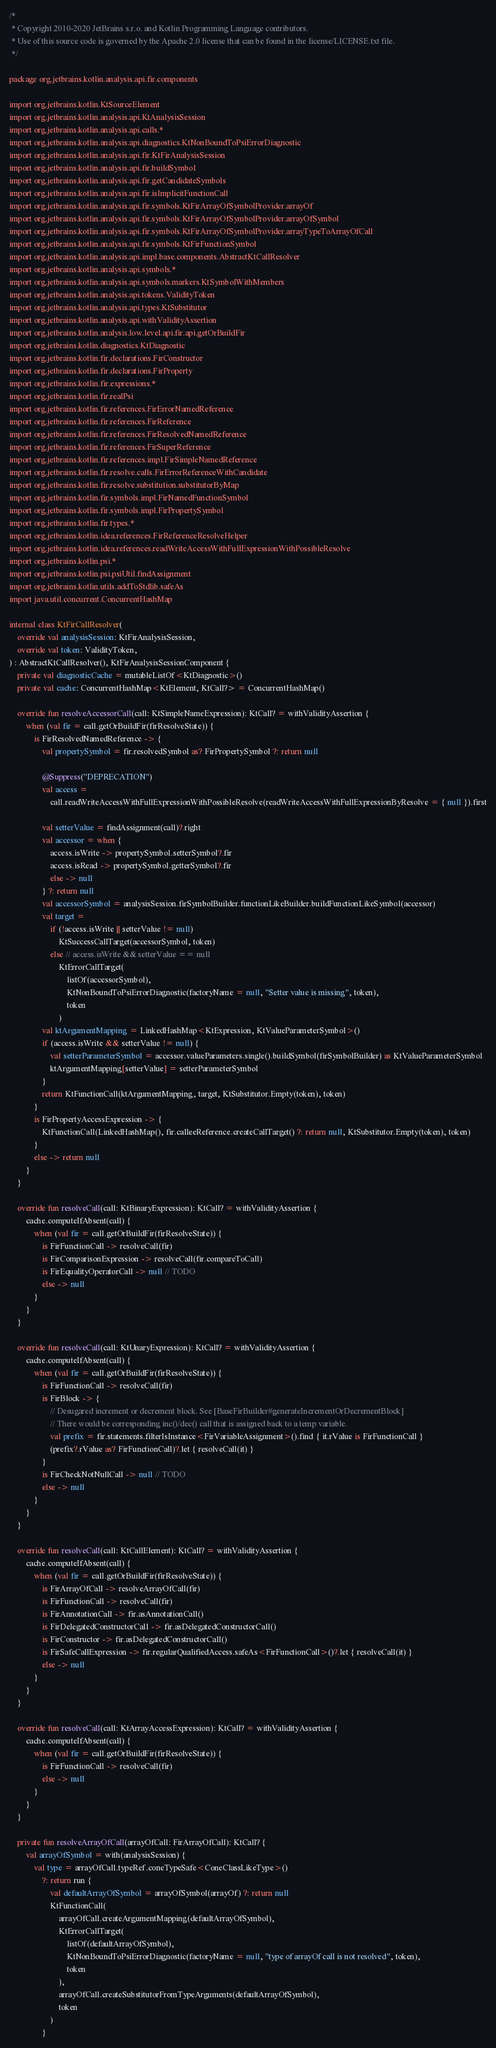<code> <loc_0><loc_0><loc_500><loc_500><_Kotlin_>/*
 * Copyright 2010-2020 JetBrains s.r.o. and Kotlin Programming Language contributors.
 * Use of this source code is governed by the Apache 2.0 license that can be found in the license/LICENSE.txt file.
 */

package org.jetbrains.kotlin.analysis.api.fir.components

import org.jetbrains.kotlin.KtSourceElement
import org.jetbrains.kotlin.analysis.api.KtAnalysisSession
import org.jetbrains.kotlin.analysis.api.calls.*
import org.jetbrains.kotlin.analysis.api.diagnostics.KtNonBoundToPsiErrorDiagnostic
import org.jetbrains.kotlin.analysis.api.fir.KtFirAnalysisSession
import org.jetbrains.kotlin.analysis.api.fir.buildSymbol
import org.jetbrains.kotlin.analysis.api.fir.getCandidateSymbols
import org.jetbrains.kotlin.analysis.api.fir.isImplicitFunctionCall
import org.jetbrains.kotlin.analysis.api.fir.symbols.KtFirArrayOfSymbolProvider.arrayOf
import org.jetbrains.kotlin.analysis.api.fir.symbols.KtFirArrayOfSymbolProvider.arrayOfSymbol
import org.jetbrains.kotlin.analysis.api.fir.symbols.KtFirArrayOfSymbolProvider.arrayTypeToArrayOfCall
import org.jetbrains.kotlin.analysis.api.fir.symbols.KtFirFunctionSymbol
import org.jetbrains.kotlin.analysis.api.impl.base.components.AbstractKtCallResolver
import org.jetbrains.kotlin.analysis.api.symbols.*
import org.jetbrains.kotlin.analysis.api.symbols.markers.KtSymbolWithMembers
import org.jetbrains.kotlin.analysis.api.tokens.ValidityToken
import org.jetbrains.kotlin.analysis.api.types.KtSubstitutor
import org.jetbrains.kotlin.analysis.api.withValidityAssertion
import org.jetbrains.kotlin.analysis.low.level.api.fir.api.getOrBuildFir
import org.jetbrains.kotlin.diagnostics.KtDiagnostic
import org.jetbrains.kotlin.fir.declarations.FirConstructor
import org.jetbrains.kotlin.fir.declarations.FirProperty
import org.jetbrains.kotlin.fir.expressions.*
import org.jetbrains.kotlin.fir.realPsi
import org.jetbrains.kotlin.fir.references.FirErrorNamedReference
import org.jetbrains.kotlin.fir.references.FirReference
import org.jetbrains.kotlin.fir.references.FirResolvedNamedReference
import org.jetbrains.kotlin.fir.references.FirSuperReference
import org.jetbrains.kotlin.fir.references.impl.FirSimpleNamedReference
import org.jetbrains.kotlin.fir.resolve.calls.FirErrorReferenceWithCandidate
import org.jetbrains.kotlin.fir.resolve.substitution.substitutorByMap
import org.jetbrains.kotlin.fir.symbols.impl.FirNamedFunctionSymbol
import org.jetbrains.kotlin.fir.symbols.impl.FirPropertySymbol
import org.jetbrains.kotlin.fir.types.*
import org.jetbrains.kotlin.idea.references.FirReferenceResolveHelper
import org.jetbrains.kotlin.idea.references.readWriteAccessWithFullExpressionWithPossibleResolve
import org.jetbrains.kotlin.psi.*
import org.jetbrains.kotlin.psi.psiUtil.findAssignment
import org.jetbrains.kotlin.utils.addToStdlib.safeAs
import java.util.concurrent.ConcurrentHashMap

internal class KtFirCallResolver(
    override val analysisSession: KtFirAnalysisSession,
    override val token: ValidityToken,
) : AbstractKtCallResolver(), KtFirAnalysisSessionComponent {
    private val diagnosticCache = mutableListOf<KtDiagnostic>()
    private val cache: ConcurrentHashMap<KtElement, KtCall?> = ConcurrentHashMap()

    override fun resolveAccessorCall(call: KtSimpleNameExpression): KtCall? = withValidityAssertion {
        when (val fir = call.getOrBuildFir(firResolveState)) {
            is FirResolvedNamedReference -> {
                val propertySymbol = fir.resolvedSymbol as? FirPropertySymbol ?: return null

                @Suppress("DEPRECATION")
                val access =
                    call.readWriteAccessWithFullExpressionWithPossibleResolve(readWriteAccessWithFullExpressionByResolve = { null }).first

                val setterValue = findAssignment(call)?.right
                val accessor = when {
                    access.isWrite -> propertySymbol.setterSymbol?.fir
                    access.isRead -> propertySymbol.getterSymbol?.fir
                    else -> null
                } ?: return null
                val accessorSymbol = analysisSession.firSymbolBuilder.functionLikeBuilder.buildFunctionLikeSymbol(accessor)
                val target =
                    if (!access.isWrite || setterValue != null)
                        KtSuccessCallTarget(accessorSymbol, token)
                    else // access.isWrite && setterValue == null
                        KtErrorCallTarget(
                            listOf(accessorSymbol),
                            KtNonBoundToPsiErrorDiagnostic(factoryName = null, "Setter value is missing", token),
                            token
                        )
                val ktArgumentMapping = LinkedHashMap<KtExpression, KtValueParameterSymbol>()
                if (access.isWrite && setterValue != null) {
                    val setterParameterSymbol = accessor.valueParameters.single().buildSymbol(firSymbolBuilder) as KtValueParameterSymbol
                    ktArgumentMapping[setterValue] = setterParameterSymbol
                }
                return KtFunctionCall(ktArgumentMapping, target, KtSubstitutor.Empty(token), token)
            }
            is FirPropertyAccessExpression -> {
                KtFunctionCall(LinkedHashMap(), fir.calleeReference.createCallTarget() ?: return null, KtSubstitutor.Empty(token), token)
            }
            else -> return null
        }
    }

    override fun resolveCall(call: KtBinaryExpression): KtCall? = withValidityAssertion {
        cache.computeIfAbsent(call) {
            when (val fir = call.getOrBuildFir(firResolveState)) {
                is FirFunctionCall -> resolveCall(fir)
                is FirComparisonExpression -> resolveCall(fir.compareToCall)
                is FirEqualityOperatorCall -> null // TODO
                else -> null
            }
        }
    }

    override fun resolveCall(call: KtUnaryExpression): KtCall? = withValidityAssertion {
        cache.computeIfAbsent(call) {
            when (val fir = call.getOrBuildFir(firResolveState)) {
                is FirFunctionCall -> resolveCall(fir)
                is FirBlock -> {
                    // Desugared increment or decrement block. See [BaseFirBuilder#generateIncrementOrDecrementBlock]
                    // There would be corresponding inc()/dec() call that is assigned back to a temp variable.
                    val prefix = fir.statements.filterIsInstance<FirVariableAssignment>().find { it.rValue is FirFunctionCall }
                    (prefix?.rValue as? FirFunctionCall)?.let { resolveCall(it) }
                }
                is FirCheckNotNullCall -> null // TODO
                else -> null
            }
        }
    }

    override fun resolveCall(call: KtCallElement): KtCall? = withValidityAssertion {
        cache.computeIfAbsent(call) {
            when (val fir = call.getOrBuildFir(firResolveState)) {
                is FirArrayOfCall -> resolveArrayOfCall(fir)
                is FirFunctionCall -> resolveCall(fir)
                is FirAnnotationCall -> fir.asAnnotationCall()
                is FirDelegatedConstructorCall -> fir.asDelegatedConstructorCall()
                is FirConstructor -> fir.asDelegatedConstructorCall()
                is FirSafeCallExpression -> fir.regularQualifiedAccess.safeAs<FirFunctionCall>()?.let { resolveCall(it) }
                else -> null
            }
        }
    }

    override fun resolveCall(call: KtArrayAccessExpression): KtCall? = withValidityAssertion {
        cache.computeIfAbsent(call) {
            when (val fir = call.getOrBuildFir(firResolveState)) {
                is FirFunctionCall -> resolveCall(fir)
                else -> null
            }
        }
    }

    private fun resolveArrayOfCall(arrayOfCall: FirArrayOfCall): KtCall? {
        val arrayOfSymbol = with(analysisSession) {
            val type = arrayOfCall.typeRef.coneTypeSafe<ConeClassLikeType>()
                ?: return run {
                    val defaultArrayOfSymbol = arrayOfSymbol(arrayOf) ?: return null
                    KtFunctionCall(
                        arrayOfCall.createArgumentMapping(defaultArrayOfSymbol),
                        KtErrorCallTarget(
                            listOf(defaultArrayOfSymbol),
                            KtNonBoundToPsiErrorDiagnostic(factoryName = null, "type of arrayOf call is not resolved", token),
                            token
                        ),
                        arrayOfCall.createSubstitutorFromTypeArguments(defaultArrayOfSymbol),
                        token
                    )
                }</code> 